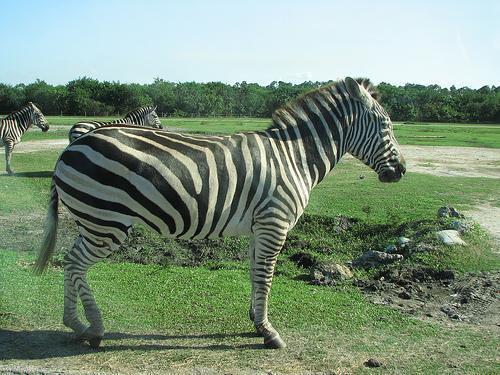How many zebras are shown?
Give a very brief answer. 3. 